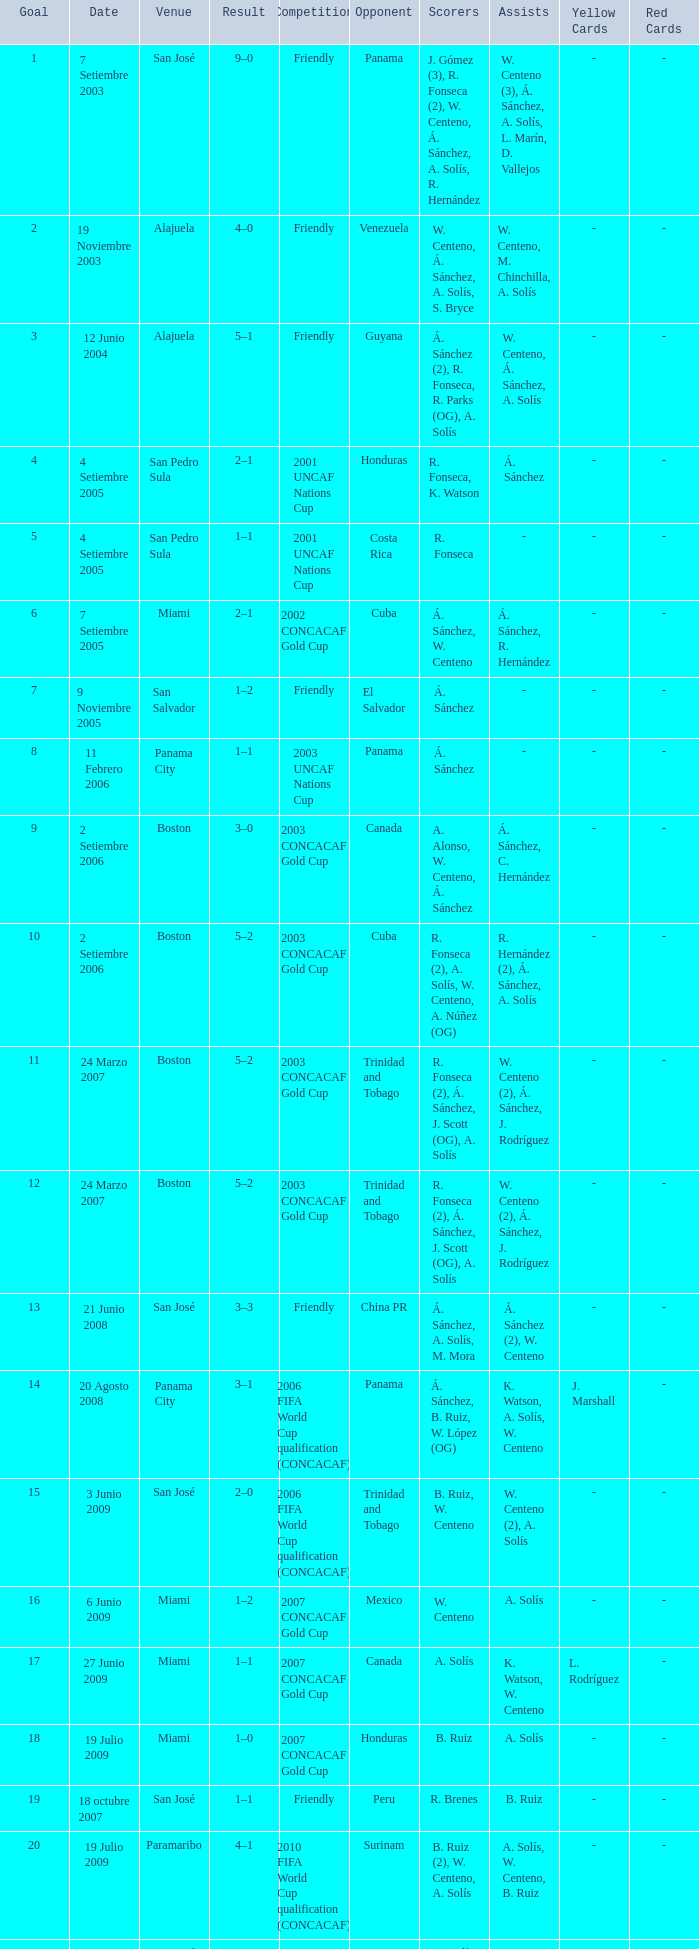How many goals were scored on 21 Junio 2008? 1.0. 